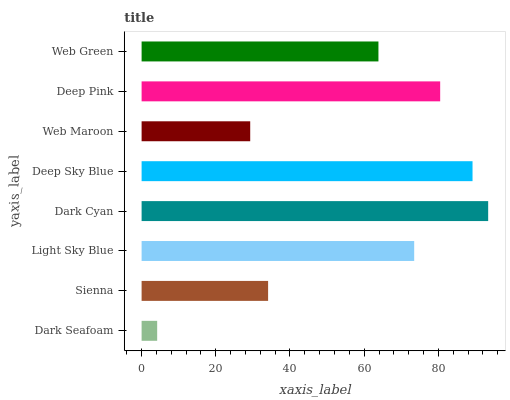Is Dark Seafoam the minimum?
Answer yes or no. Yes. Is Dark Cyan the maximum?
Answer yes or no. Yes. Is Sienna the minimum?
Answer yes or no. No. Is Sienna the maximum?
Answer yes or no. No. Is Sienna greater than Dark Seafoam?
Answer yes or no. Yes. Is Dark Seafoam less than Sienna?
Answer yes or no. Yes. Is Dark Seafoam greater than Sienna?
Answer yes or no. No. Is Sienna less than Dark Seafoam?
Answer yes or no. No. Is Light Sky Blue the high median?
Answer yes or no. Yes. Is Web Green the low median?
Answer yes or no. Yes. Is Deep Pink the high median?
Answer yes or no. No. Is Sienna the low median?
Answer yes or no. No. 